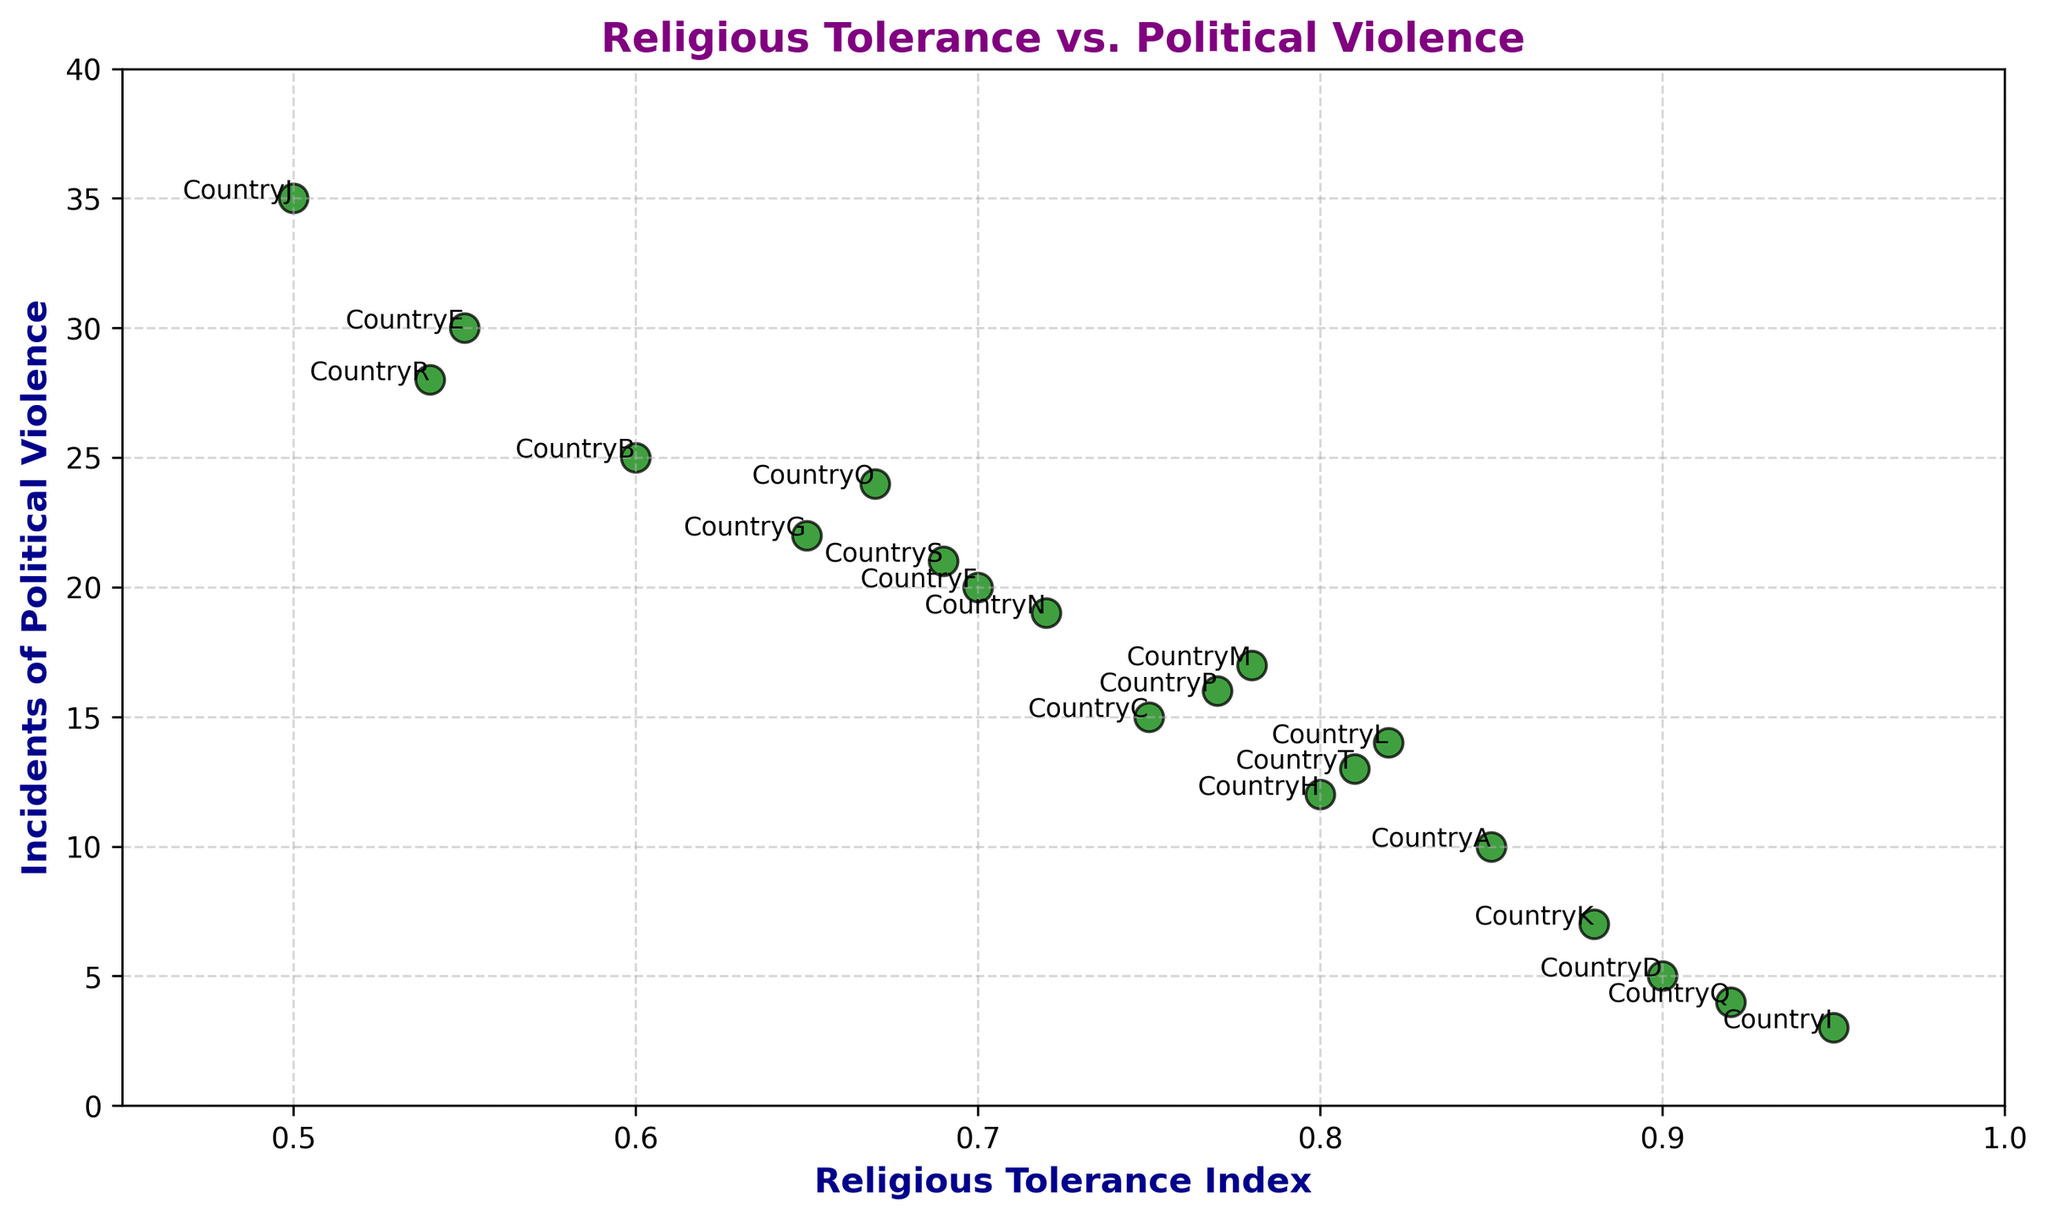What is the general trend between Religious Tolerance Index and Incidents of Political Violence? By observing the scatter plot, countries with higher Religious Tolerance Index tend to have fewer Incidents of Political Violence. The points with higher indices are lower on the y-axis, indicating fewer incidents.
Answer: Negative correlation Which country has the highest Religious Tolerance Index? By looking at the x-axis, Country I has the highest Religious Tolerance Index as it is plotted at the far right of the graph.
Answer: Country I What is the relationship between Country J and Country I in terms of religious tolerance and political violence? Country I is at the high end of religious tolerance (0.95) with low political violence incidents (3), while Country J has the lowest religious tolerance (0.50) and the highest incidents of political violence (35). The comparison shows inverse relations for these two countries.
Answer: Inversely proportional Which countries have a Religious Tolerance Index greater than 0.85? By observing the scatter plot on the x-axis greater than 0.85, the countries that meet this criterion are Country A, Country D, Country I, Country K, and Country Q.
Answer: Countries A, D, I, K, Q How many incidents of political violence are reported for Country K? By locating Country K's annotation on the scatter plot, it has 7 incidents of political violence, noted by its position on the y-axis.
Answer: 7 Which country has the closest relationship of incidents of political violence to the median value? Calculating the median value for political violence (between 3 and 35), which is around 17-18, the country closest in value is Country N with 19 incidents.
Answer: Country N What is the difference in political violence incidents between Country E and Country Q? Country E has 30 incidents, and Country Q has 4. The difference is calculated by subtracting 4 from 30, which is 26.
Answer: 26 Which countries have a Religious Tolerance Index between 0.70 and 0.80? Observing all points plotted between these values on the x-axis, the countries are Country C, Country H, Country M, and Country P.
Answer: Countries C, H, M, P 